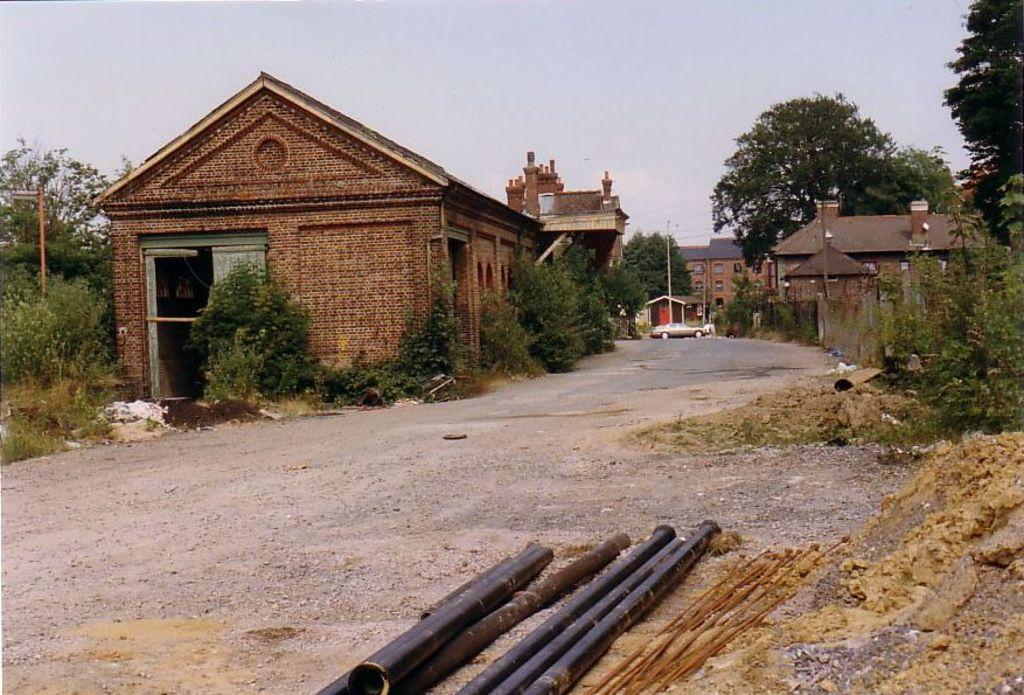Please provide a concise description of this image. In the center of the image there are sheds and we can see a car on the road. At the bottom there are rods. In the background we can see trees and sky. 